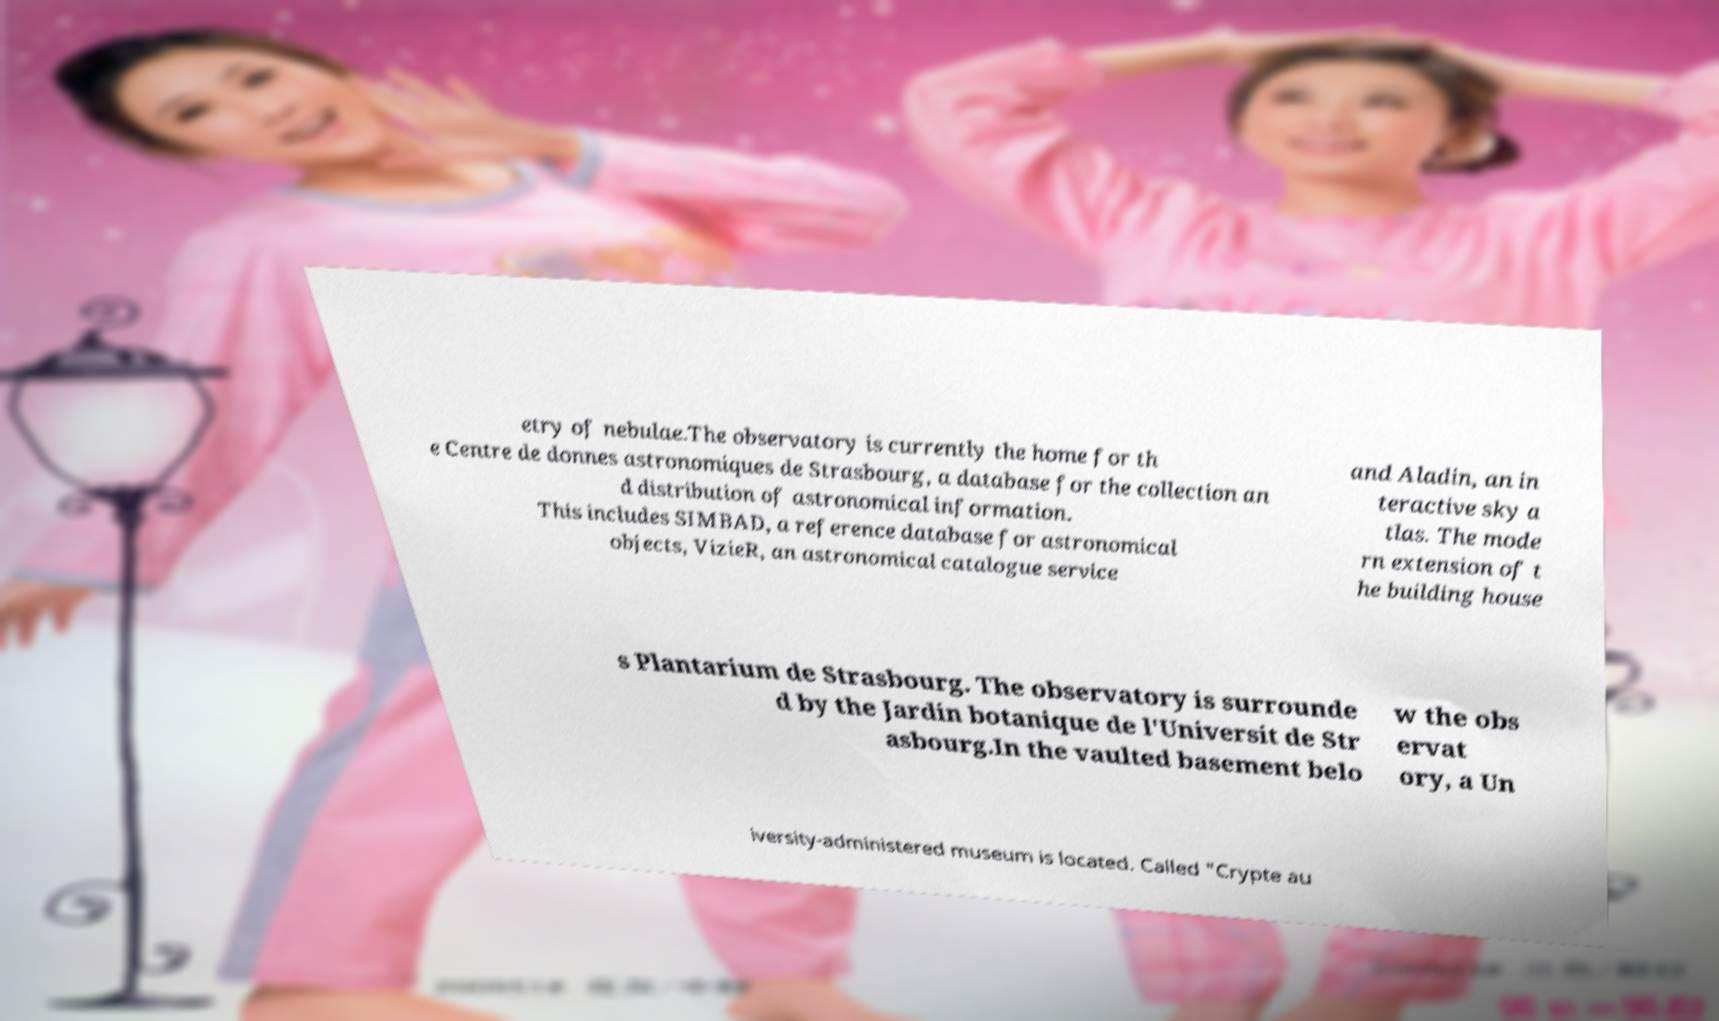Can you accurately transcribe the text from the provided image for me? etry of nebulae.The observatory is currently the home for th e Centre de donnes astronomiques de Strasbourg, a database for the collection an d distribution of astronomical information. This includes SIMBAD, a reference database for astronomical objects, VizieR, an astronomical catalogue service and Aladin, an in teractive sky a tlas. The mode rn extension of t he building house s Plantarium de Strasbourg. The observatory is surrounde d by the Jardin botanique de l'Universit de Str asbourg.In the vaulted basement belo w the obs ervat ory, a Un iversity-administered museum is located. Called "Crypte au 